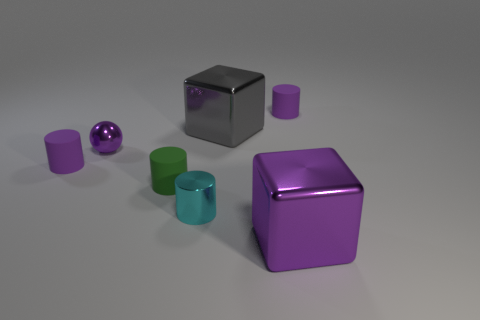Subtract all green cubes. Subtract all green balls. How many cubes are left? 2 Add 1 tiny green balls. How many objects exist? 8 Subtract all balls. How many objects are left? 6 Add 4 tiny purple rubber cylinders. How many tiny purple rubber cylinders are left? 6 Add 2 gray metal things. How many gray metal things exist? 3 Subtract 0 cyan balls. How many objects are left? 7 Subtract all tiny green rubber things. Subtract all large cyan shiny objects. How many objects are left? 6 